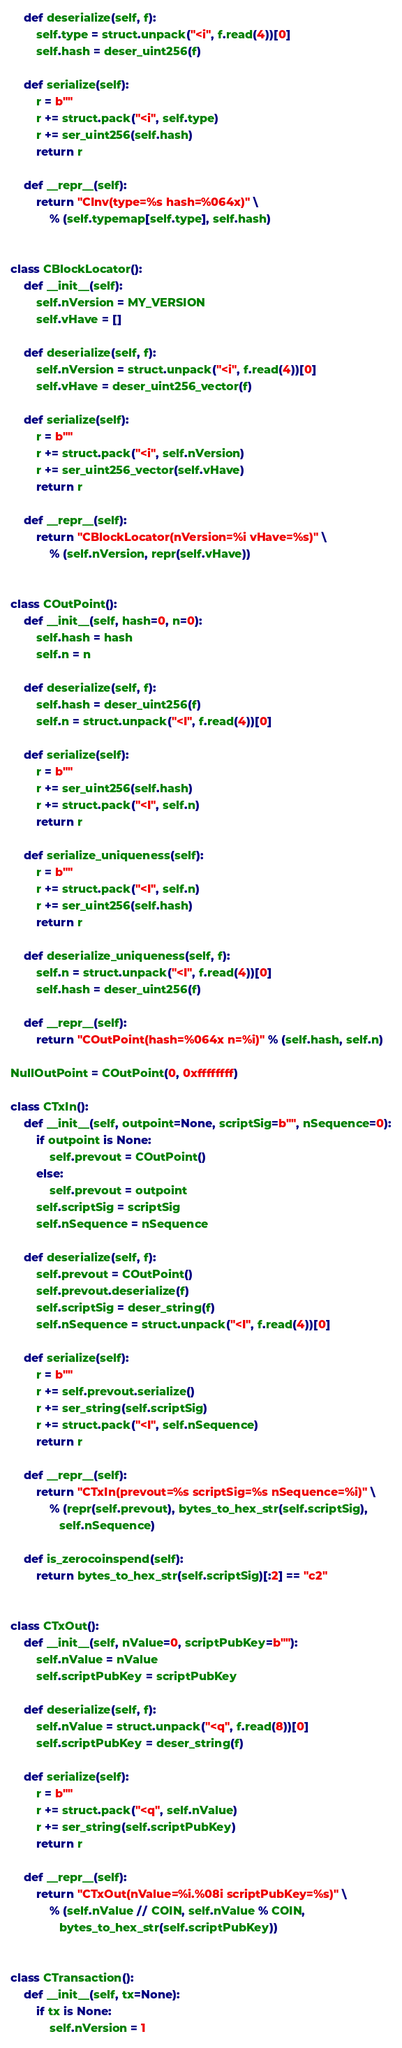<code> <loc_0><loc_0><loc_500><loc_500><_Python_>    def deserialize(self, f):
        self.type = struct.unpack("<i", f.read(4))[0]
        self.hash = deser_uint256(f)

    def serialize(self):
        r = b""
        r += struct.pack("<i", self.type)
        r += ser_uint256(self.hash)
        return r

    def __repr__(self):
        return "CInv(type=%s hash=%064x)" \
            % (self.typemap[self.type], self.hash)


class CBlockLocator():
    def __init__(self):
        self.nVersion = MY_VERSION
        self.vHave = []

    def deserialize(self, f):
        self.nVersion = struct.unpack("<i", f.read(4))[0]
        self.vHave = deser_uint256_vector(f)

    def serialize(self):
        r = b""
        r += struct.pack("<i", self.nVersion)
        r += ser_uint256_vector(self.vHave)
        return r

    def __repr__(self):
        return "CBlockLocator(nVersion=%i vHave=%s)" \
            % (self.nVersion, repr(self.vHave))


class COutPoint():
    def __init__(self, hash=0, n=0):
        self.hash = hash
        self.n = n

    def deserialize(self, f):
        self.hash = deser_uint256(f)
        self.n = struct.unpack("<I", f.read(4))[0]

    def serialize(self):
        r = b""
        r += ser_uint256(self.hash)
        r += struct.pack("<I", self.n)
        return r

    def serialize_uniqueness(self):
        r = b""
        r += struct.pack("<I", self.n)
        r += ser_uint256(self.hash)
        return r

    def deserialize_uniqueness(self, f):
        self.n = struct.unpack("<I", f.read(4))[0]
        self.hash = deser_uint256(f)

    def __repr__(self):
        return "COutPoint(hash=%064x n=%i)" % (self.hash, self.n)

NullOutPoint = COutPoint(0, 0xffffffff)

class CTxIn():
    def __init__(self, outpoint=None, scriptSig=b"", nSequence=0):
        if outpoint is None:
            self.prevout = COutPoint()
        else:
            self.prevout = outpoint
        self.scriptSig = scriptSig
        self.nSequence = nSequence

    def deserialize(self, f):
        self.prevout = COutPoint()
        self.prevout.deserialize(f)
        self.scriptSig = deser_string(f)
        self.nSequence = struct.unpack("<I", f.read(4))[0]

    def serialize(self):
        r = b""
        r += self.prevout.serialize()
        r += ser_string(self.scriptSig)
        r += struct.pack("<I", self.nSequence)
        return r

    def __repr__(self):
        return "CTxIn(prevout=%s scriptSig=%s nSequence=%i)" \
            % (repr(self.prevout), bytes_to_hex_str(self.scriptSig),
               self.nSequence)

    def is_zerocoinspend(self):
        return bytes_to_hex_str(self.scriptSig)[:2] == "c2"


class CTxOut():
    def __init__(self, nValue=0, scriptPubKey=b""):
        self.nValue = nValue
        self.scriptPubKey = scriptPubKey

    def deserialize(self, f):
        self.nValue = struct.unpack("<q", f.read(8))[0]
        self.scriptPubKey = deser_string(f)

    def serialize(self):
        r = b""
        r += struct.pack("<q", self.nValue)
        r += ser_string(self.scriptPubKey)
        return r

    def __repr__(self):
        return "CTxOut(nValue=%i.%08i scriptPubKey=%s)" \
            % (self.nValue // COIN, self.nValue % COIN,
               bytes_to_hex_str(self.scriptPubKey))


class CTransaction():
    def __init__(self, tx=None):
        if tx is None:
            self.nVersion = 1</code> 